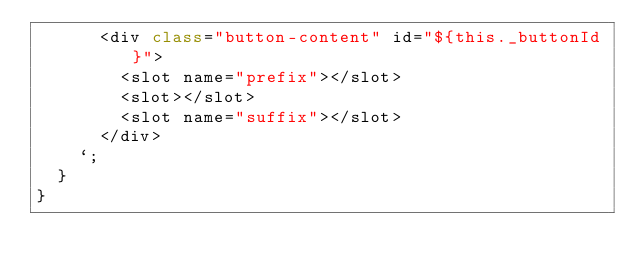Convert code to text. <code><loc_0><loc_0><loc_500><loc_500><_JavaScript_>      <div class="button-content" id="${this._buttonId}">
        <slot name="prefix"></slot>
        <slot></slot>
        <slot name="suffix"></slot>
      </div>
    `;
  }
}
</code> 